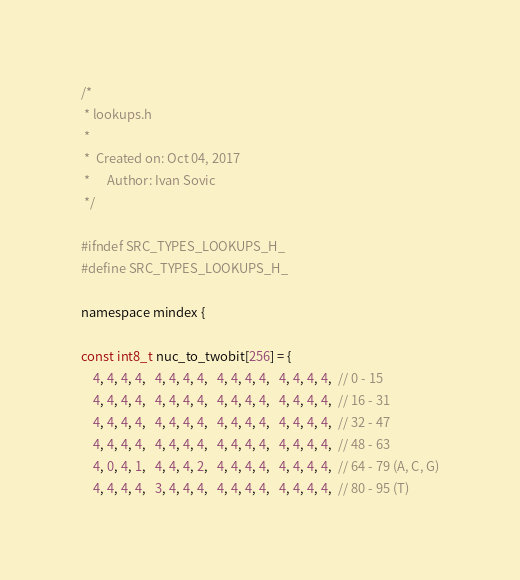<code> <loc_0><loc_0><loc_500><loc_500><_C_>/*
 * lookups.h
 *
 *  Created on: Oct 04, 2017
 *      Author: Ivan Sovic
 */

#ifndef SRC_TYPES_LOOKUPS_H_
#define SRC_TYPES_LOOKUPS_H_

namespace mindex {

const int8_t nuc_to_twobit[256] = {
    4, 4, 4, 4,   4, 4, 4, 4,   4, 4, 4, 4,   4, 4, 4, 4,  // 0 - 15
    4, 4, 4, 4,   4, 4, 4, 4,   4, 4, 4, 4,   4, 4, 4, 4,  // 16 - 31
    4, 4, 4, 4,   4, 4, 4, 4,   4, 4, 4, 4,   4, 4, 4, 4,  // 32 - 47
    4, 4, 4, 4,   4, 4, 4, 4,   4, 4, 4, 4,   4, 4, 4, 4,  // 48 - 63
    4, 0, 4, 1,   4, 4, 4, 2,   4, 4, 4, 4,   4, 4, 4, 4,  // 64 - 79 (A, C, G)
    4, 4, 4, 4,   3, 4, 4, 4,   4, 4, 4, 4,   4, 4, 4, 4,  // 80 - 95 (T)</code> 